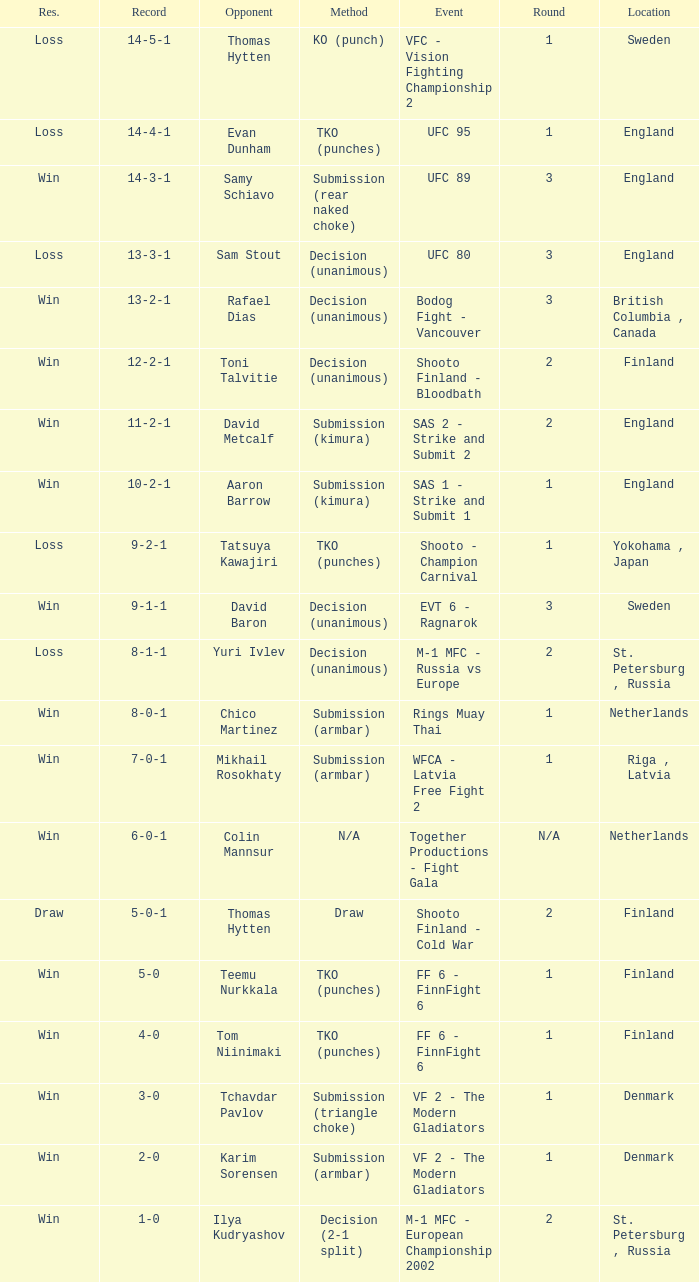Which round in finland utilizes a draw for its method? 2.0. 